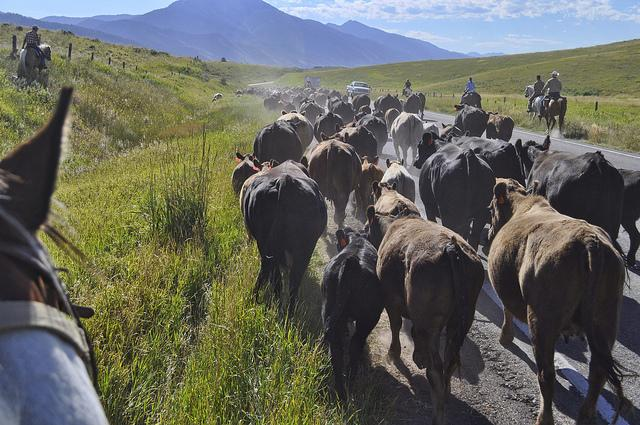What tragedy can happen here?

Choices:
A) earthquake
B) fire
C) cows hit
D) volcano eruption cows hit 